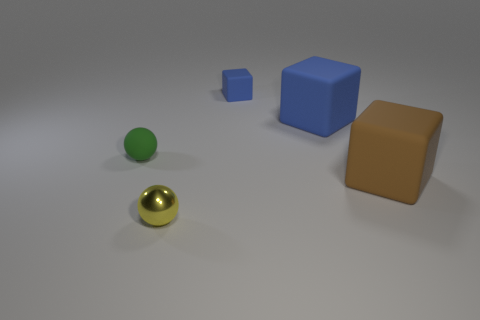Add 3 blue matte things. How many objects exist? 8 Subtract all spheres. How many objects are left? 3 Add 1 blue matte blocks. How many blue matte blocks are left? 3 Add 1 metal balls. How many metal balls exist? 2 Subtract 0 cyan cubes. How many objects are left? 5 Subtract all tiny matte blocks. Subtract all small spheres. How many objects are left? 2 